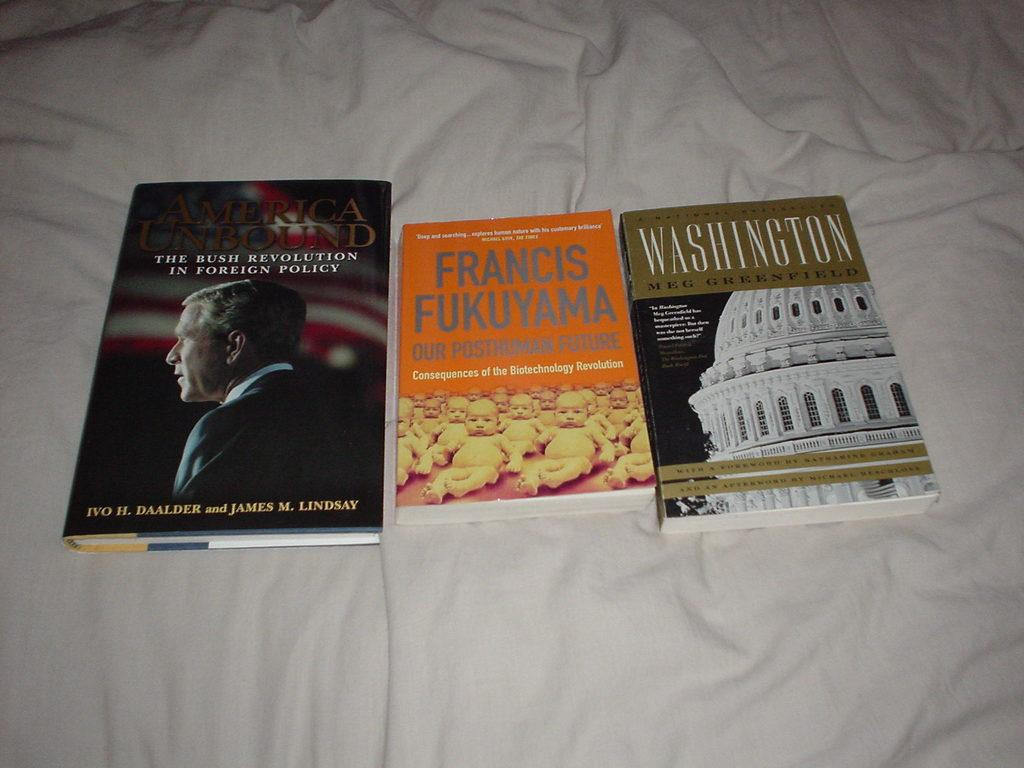<image>
Provide a brief description of the given image. Three books, one of which is about George Bush. 